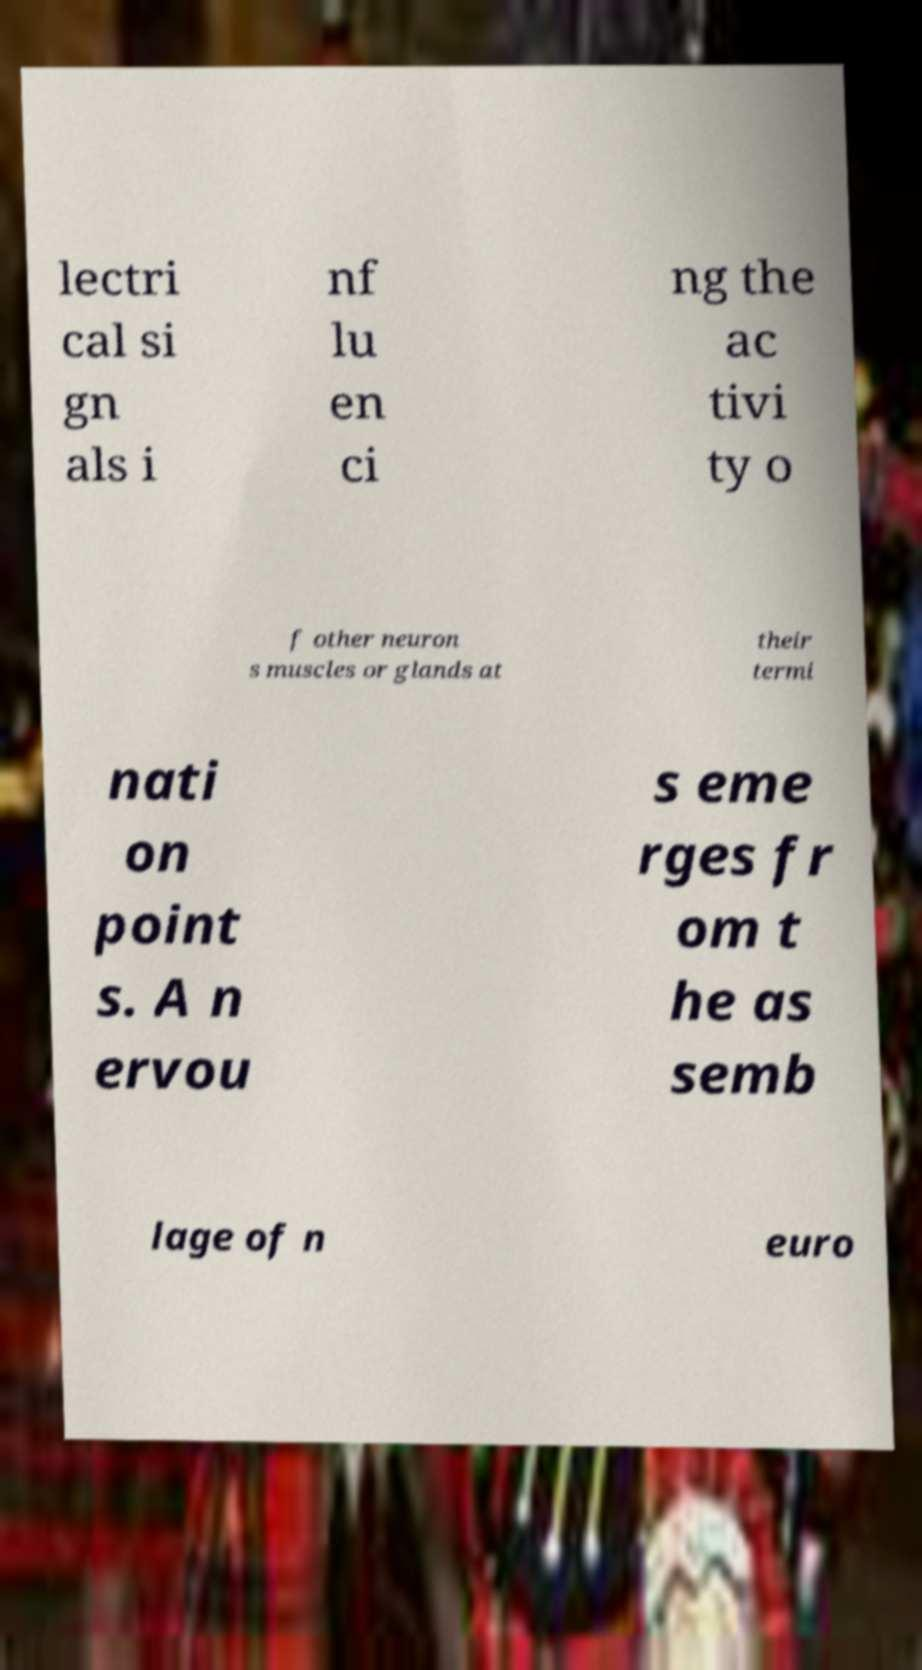Could you assist in decoding the text presented in this image and type it out clearly? lectri cal si gn als i nf lu en ci ng the ac tivi ty o f other neuron s muscles or glands at their termi nati on point s. A n ervou s eme rges fr om t he as semb lage of n euro 